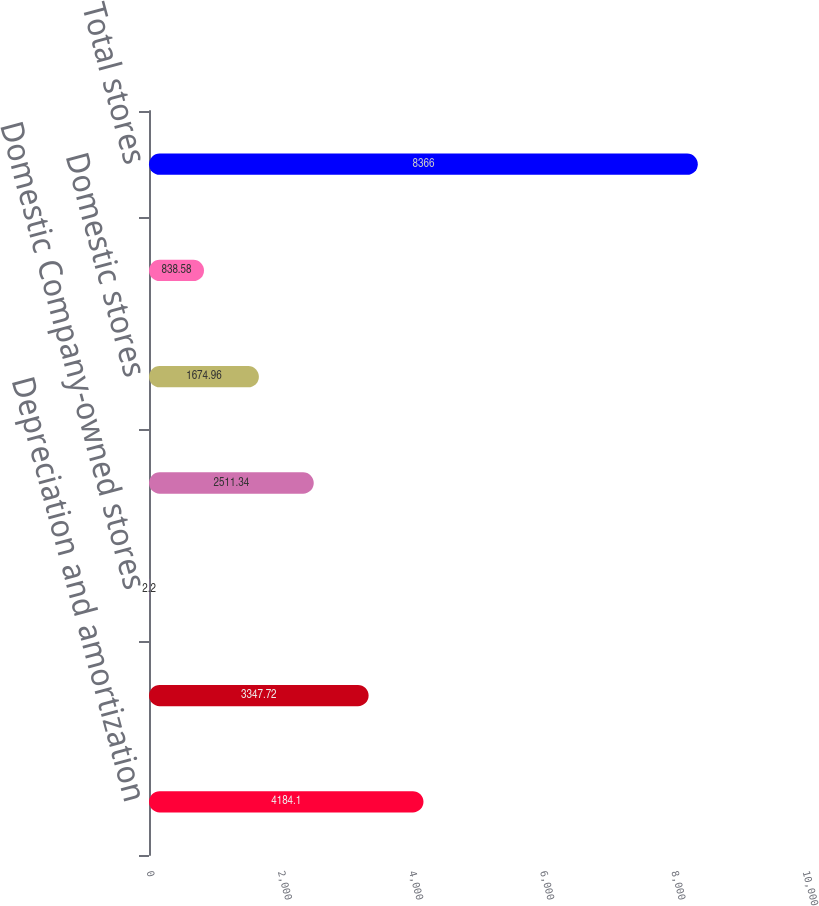Convert chart to OTSL. <chart><loc_0><loc_0><loc_500><loc_500><bar_chart><fcel>Depreciation and amortization<fcel>Capital expenditures<fcel>Domestic Company-owned stores<fcel>Domestic franchise stores<fcel>Domestic stores<fcel>International stores<fcel>Total stores<nl><fcel>4184.1<fcel>3347.72<fcel>2.2<fcel>2511.34<fcel>1674.96<fcel>838.58<fcel>8366<nl></chart> 